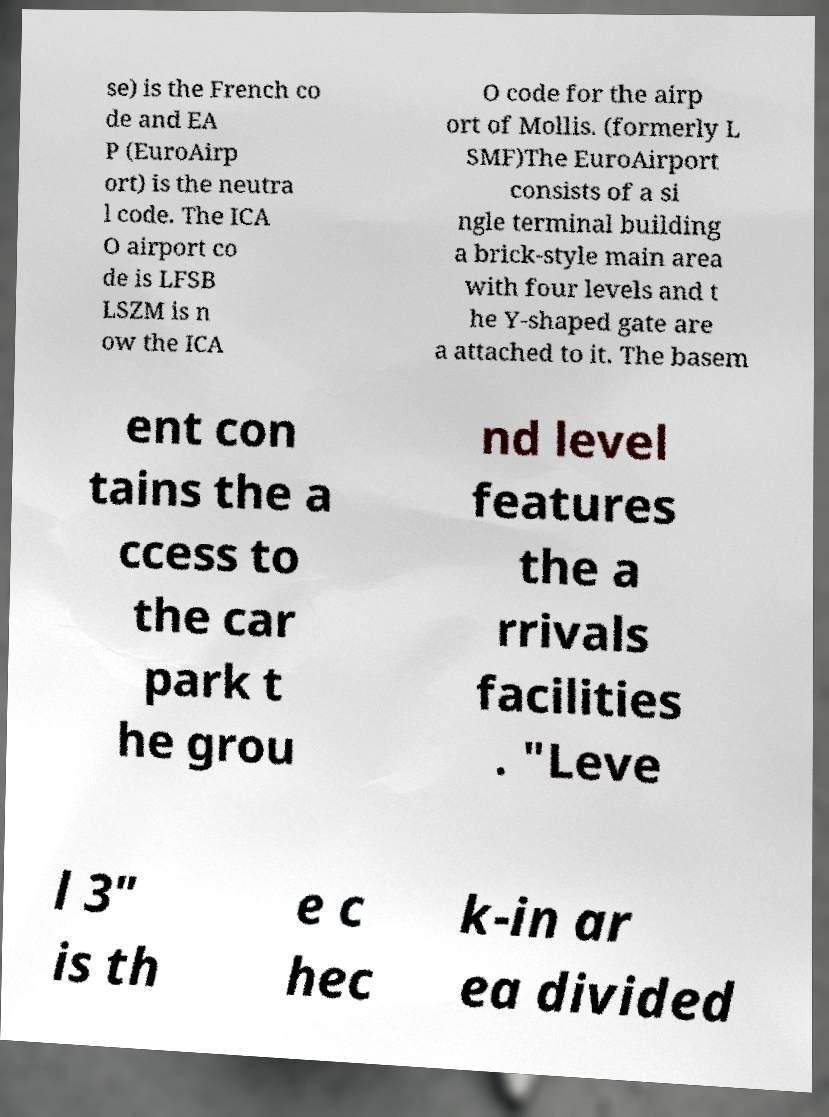Please read and relay the text visible in this image. What does it say? se) is the French co de and EA P (EuroAirp ort) is the neutra l code. The ICA O airport co de is LFSB LSZM is n ow the ICA O code for the airp ort of Mollis. (formerly L SMF)The EuroAirport consists of a si ngle terminal building a brick-style main area with four levels and t he Y-shaped gate are a attached to it. The basem ent con tains the a ccess to the car park t he grou nd level features the a rrivals facilities . "Leve l 3" is th e c hec k-in ar ea divided 